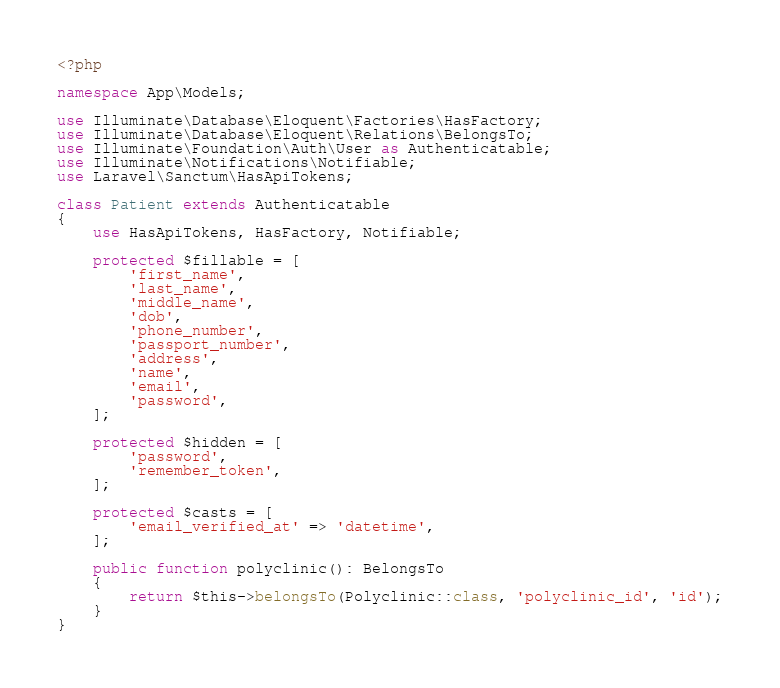<code> <loc_0><loc_0><loc_500><loc_500><_PHP_><?php

namespace App\Models;

use Illuminate\Database\Eloquent\Factories\HasFactory;
use Illuminate\Database\Eloquent\Relations\BelongsTo;
use Illuminate\Foundation\Auth\User as Authenticatable;
use Illuminate\Notifications\Notifiable;
use Laravel\Sanctum\HasApiTokens;

class Patient extends Authenticatable
{
    use HasApiTokens, HasFactory, Notifiable;

    protected $fillable = [
        'first_name',
        'last_name',
        'middle_name',
        'dob',
        'phone_number',
        'passport_number',
        'address',
        'name',
        'email',
        'password',
    ];

    protected $hidden = [
        'password',
        'remember_token',
    ];

    protected $casts = [
        'email_verified_at' => 'datetime',
    ];

    public function polyclinic(): BelongsTo
    {
        return $this->belongsTo(Polyclinic::class, 'polyclinic_id', 'id');
    }
}
</code> 